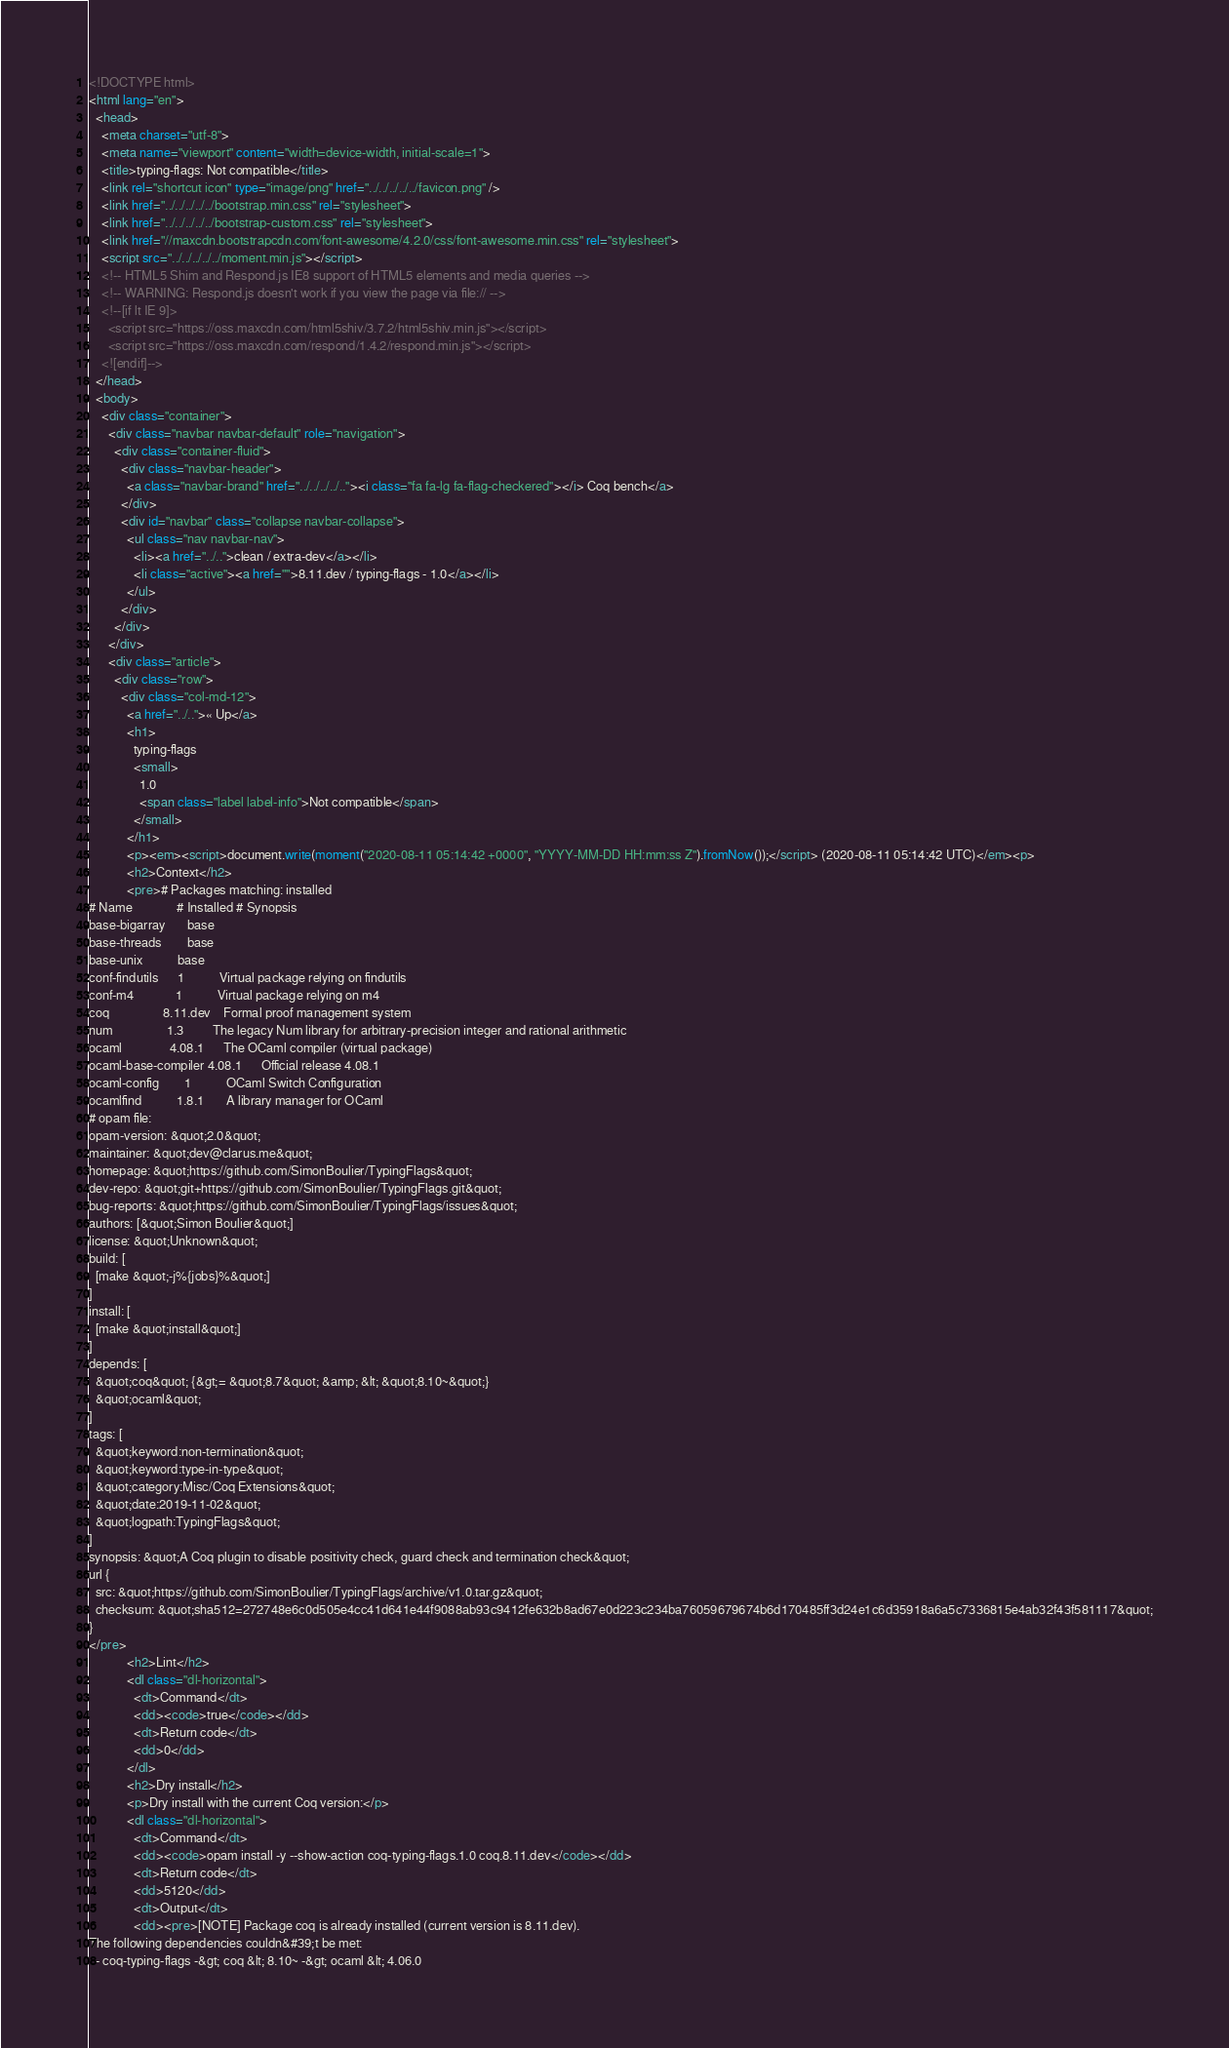<code> <loc_0><loc_0><loc_500><loc_500><_HTML_><!DOCTYPE html>
<html lang="en">
  <head>
    <meta charset="utf-8">
    <meta name="viewport" content="width=device-width, initial-scale=1">
    <title>typing-flags: Not compatible</title>
    <link rel="shortcut icon" type="image/png" href="../../../../../favicon.png" />
    <link href="../../../../../bootstrap.min.css" rel="stylesheet">
    <link href="../../../../../bootstrap-custom.css" rel="stylesheet">
    <link href="//maxcdn.bootstrapcdn.com/font-awesome/4.2.0/css/font-awesome.min.css" rel="stylesheet">
    <script src="../../../../../moment.min.js"></script>
    <!-- HTML5 Shim and Respond.js IE8 support of HTML5 elements and media queries -->
    <!-- WARNING: Respond.js doesn't work if you view the page via file:// -->
    <!--[if lt IE 9]>
      <script src="https://oss.maxcdn.com/html5shiv/3.7.2/html5shiv.min.js"></script>
      <script src="https://oss.maxcdn.com/respond/1.4.2/respond.min.js"></script>
    <![endif]-->
  </head>
  <body>
    <div class="container">
      <div class="navbar navbar-default" role="navigation">
        <div class="container-fluid">
          <div class="navbar-header">
            <a class="navbar-brand" href="../../../../.."><i class="fa fa-lg fa-flag-checkered"></i> Coq bench</a>
          </div>
          <div id="navbar" class="collapse navbar-collapse">
            <ul class="nav navbar-nav">
              <li><a href="../..">clean / extra-dev</a></li>
              <li class="active"><a href="">8.11.dev / typing-flags - 1.0</a></li>
            </ul>
          </div>
        </div>
      </div>
      <div class="article">
        <div class="row">
          <div class="col-md-12">
            <a href="../..">« Up</a>
            <h1>
              typing-flags
              <small>
                1.0
                <span class="label label-info">Not compatible</span>
              </small>
            </h1>
            <p><em><script>document.write(moment("2020-08-11 05:14:42 +0000", "YYYY-MM-DD HH:mm:ss Z").fromNow());</script> (2020-08-11 05:14:42 UTC)</em><p>
            <h2>Context</h2>
            <pre># Packages matching: installed
# Name              # Installed # Synopsis
base-bigarray       base
base-threads        base
base-unix           base
conf-findutils      1           Virtual package relying on findutils
conf-m4             1           Virtual package relying on m4
coq                 8.11.dev    Formal proof management system
num                 1.3         The legacy Num library for arbitrary-precision integer and rational arithmetic
ocaml               4.08.1      The OCaml compiler (virtual package)
ocaml-base-compiler 4.08.1      Official release 4.08.1
ocaml-config        1           OCaml Switch Configuration
ocamlfind           1.8.1       A library manager for OCaml
# opam file:
opam-version: &quot;2.0&quot;
maintainer: &quot;dev@clarus.me&quot;
homepage: &quot;https://github.com/SimonBoulier/TypingFlags&quot;
dev-repo: &quot;git+https://github.com/SimonBoulier/TypingFlags.git&quot;
bug-reports: &quot;https://github.com/SimonBoulier/TypingFlags/issues&quot;
authors: [&quot;Simon Boulier&quot;]
license: &quot;Unknown&quot;
build: [
  [make &quot;-j%{jobs}%&quot;]
]
install: [
  [make &quot;install&quot;]
]
depends: [
  &quot;coq&quot; {&gt;= &quot;8.7&quot; &amp; &lt; &quot;8.10~&quot;}
  &quot;ocaml&quot;
]
tags: [
  &quot;keyword:non-termination&quot;
  &quot;keyword:type-in-type&quot;
  &quot;category:Misc/Coq Extensions&quot;
  &quot;date:2019-11-02&quot;
  &quot;logpath:TypingFlags&quot;
]
synopsis: &quot;A Coq plugin to disable positivity check, guard check and termination check&quot;
url {
  src: &quot;https://github.com/SimonBoulier/TypingFlags/archive/v1.0.tar.gz&quot;
  checksum: &quot;sha512=272748e6c0d505e4cc41d641e44f9088ab93c9412fe632b8ad67e0d223c234ba76059679674b6d170485ff3d24e1c6d35918a6a5c7336815e4ab32f43f581117&quot;
}
</pre>
            <h2>Lint</h2>
            <dl class="dl-horizontal">
              <dt>Command</dt>
              <dd><code>true</code></dd>
              <dt>Return code</dt>
              <dd>0</dd>
            </dl>
            <h2>Dry install</h2>
            <p>Dry install with the current Coq version:</p>
            <dl class="dl-horizontal">
              <dt>Command</dt>
              <dd><code>opam install -y --show-action coq-typing-flags.1.0 coq.8.11.dev</code></dd>
              <dt>Return code</dt>
              <dd>5120</dd>
              <dt>Output</dt>
              <dd><pre>[NOTE] Package coq is already installed (current version is 8.11.dev).
The following dependencies couldn&#39;t be met:
  - coq-typing-flags -&gt; coq &lt; 8.10~ -&gt; ocaml &lt; 4.06.0</code> 